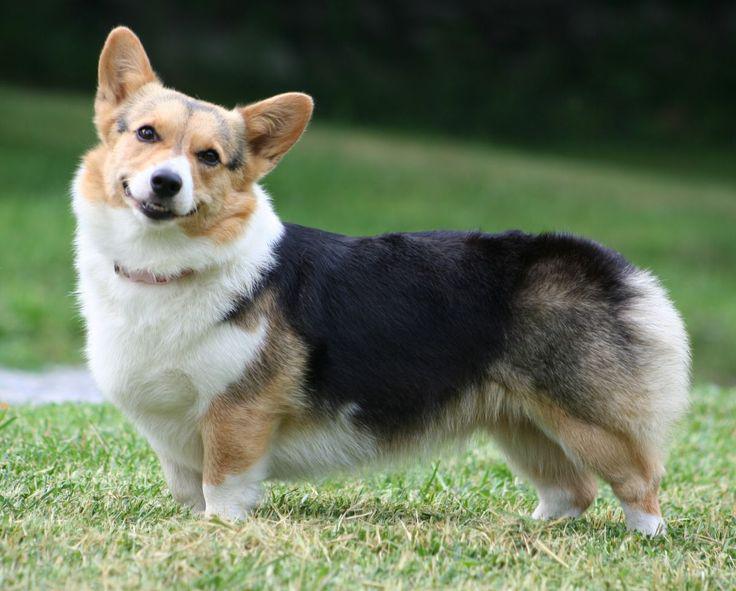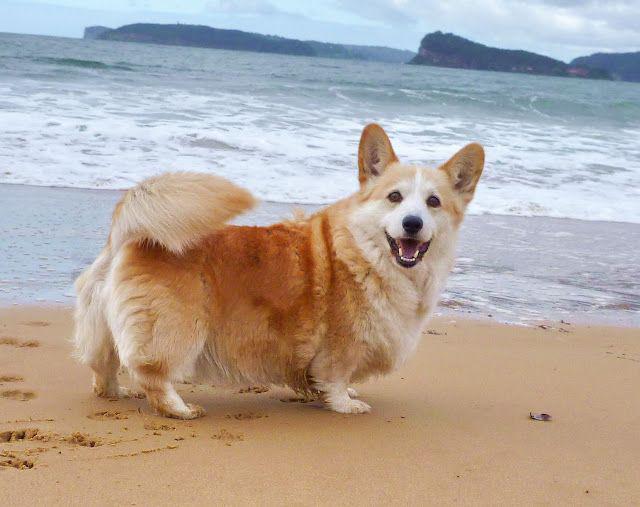The first image is the image on the left, the second image is the image on the right. For the images shown, is this caption "The dog in the image on the right is near a body of water." true? Answer yes or no. Yes. The first image is the image on the left, the second image is the image on the right. Assess this claim about the two images: "An image shows one orange-and-white corgi dog posed on the shore in front of water and looking at the camera.". Correct or not? Answer yes or no. Yes. 